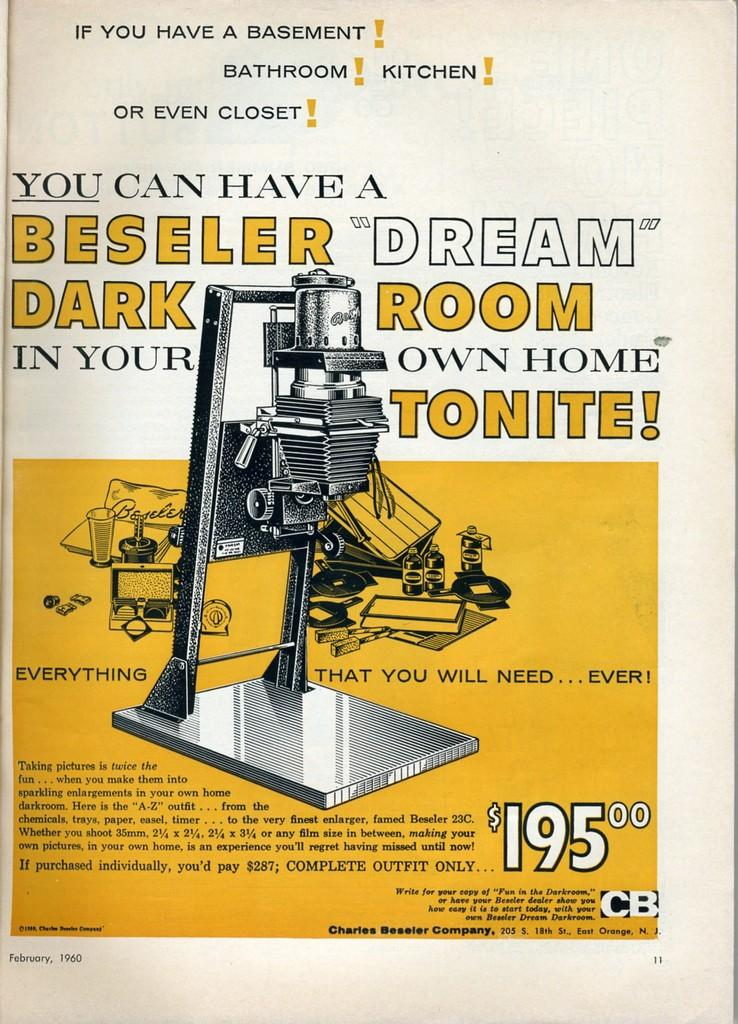<image>
Summarize the visual content of the image. An old ad for a kit to turn any dark room into a dark room for photos for $195. 